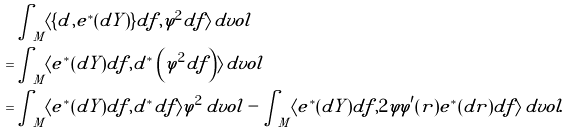<formula> <loc_0><loc_0><loc_500><loc_500>& \int _ { M } \langle \{ d , e ^ { * } ( d Y ) \} d f , \varphi ^ { 2 } d f \rangle \, d v o l \\ = & \int _ { M } \langle e ^ { * } ( d Y ) d f , d ^ { * } \left ( \varphi ^ { 2 } d f \right ) \rangle \, d v o l \\ = & \int _ { M } \langle e ^ { * } ( d Y ) d f , d ^ { * } d f \rangle \varphi ^ { 2 } \, d v o l - \int _ { M } \langle e ^ { * } ( d Y ) d f , 2 \varphi \varphi ^ { \prime } ( r ) e ^ { * } ( d r ) d f \rangle \, d v o l .</formula> 